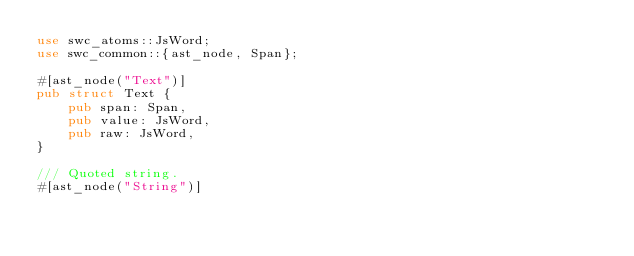Convert code to text. <code><loc_0><loc_0><loc_500><loc_500><_Rust_>use swc_atoms::JsWord;
use swc_common::{ast_node, Span};

#[ast_node("Text")]
pub struct Text {
    pub span: Span,
    pub value: JsWord,
    pub raw: JsWord,
}

/// Quoted string.
#[ast_node("String")]</code> 